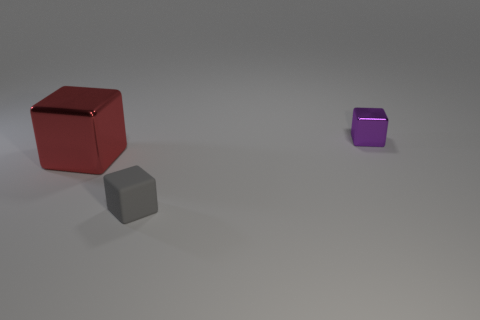Is there any other thing that has the same material as the gray cube?
Keep it short and to the point. No. There is a gray rubber object that is the same shape as the small purple object; what is its size?
Give a very brief answer. Small. Do the red block and the tiny block on the right side of the small rubber cube have the same material?
Your answer should be very brief. Yes. What number of metal things are either small cubes or brown things?
Your answer should be very brief. 1. There is a metal cube that is left of the tiny gray cube; what size is it?
Give a very brief answer. Large. The other block that is made of the same material as the small purple cube is what size?
Your answer should be compact. Large. How many blocks have the same color as the large shiny thing?
Make the answer very short. 0. Is there a tiny brown matte thing?
Make the answer very short. No. What is the color of the tiny thing that is in front of the tiny block right of the small cube on the left side of the tiny metal object?
Offer a very short reply. Gray. Are there any small blocks left of the large red shiny object?
Keep it short and to the point. No. 